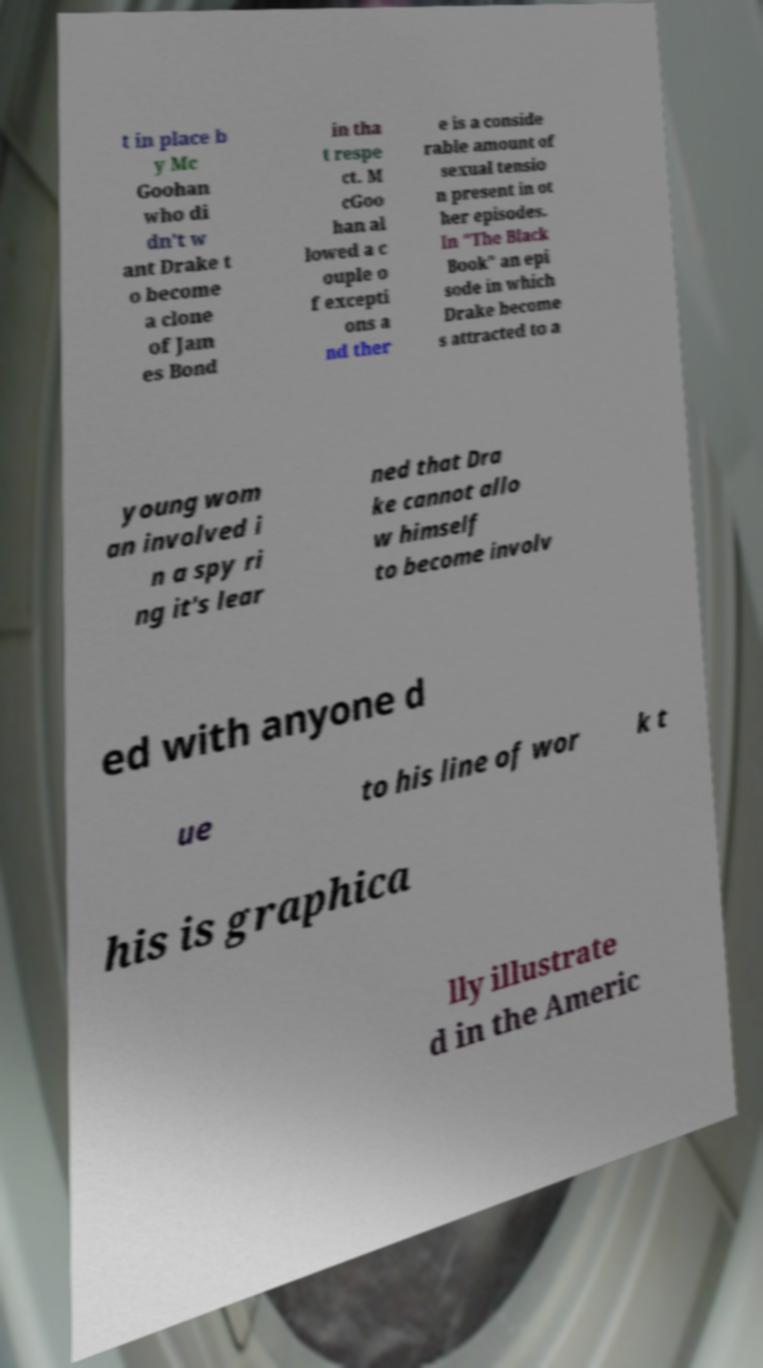Could you assist in decoding the text presented in this image and type it out clearly? t in place b y Mc Goohan who di dn't w ant Drake t o become a clone of Jam es Bond in tha t respe ct. M cGoo han al lowed a c ouple o f excepti ons a nd ther e is a conside rable amount of sexual tensio n present in ot her episodes. In "The Black Book" an epi sode in which Drake become s attracted to a young wom an involved i n a spy ri ng it's lear ned that Dra ke cannot allo w himself to become involv ed with anyone d ue to his line of wor k t his is graphica lly illustrate d in the Americ 